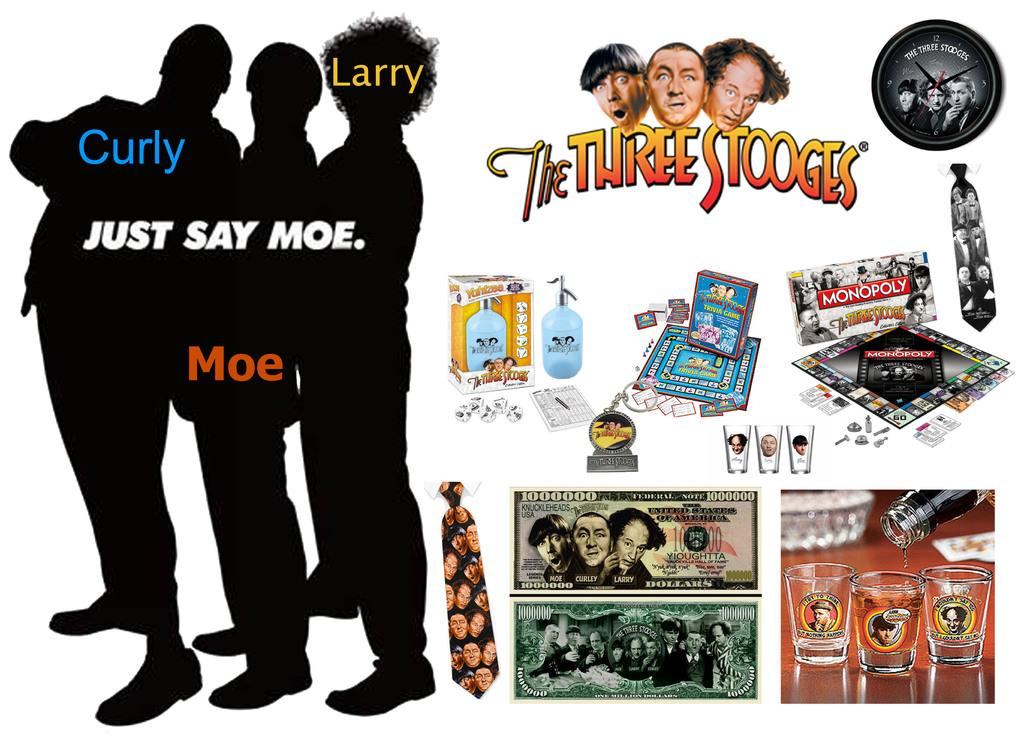<image>
Create a compact narrative representing the image presented. Collage of photos including one that says "The Three Stooges". 